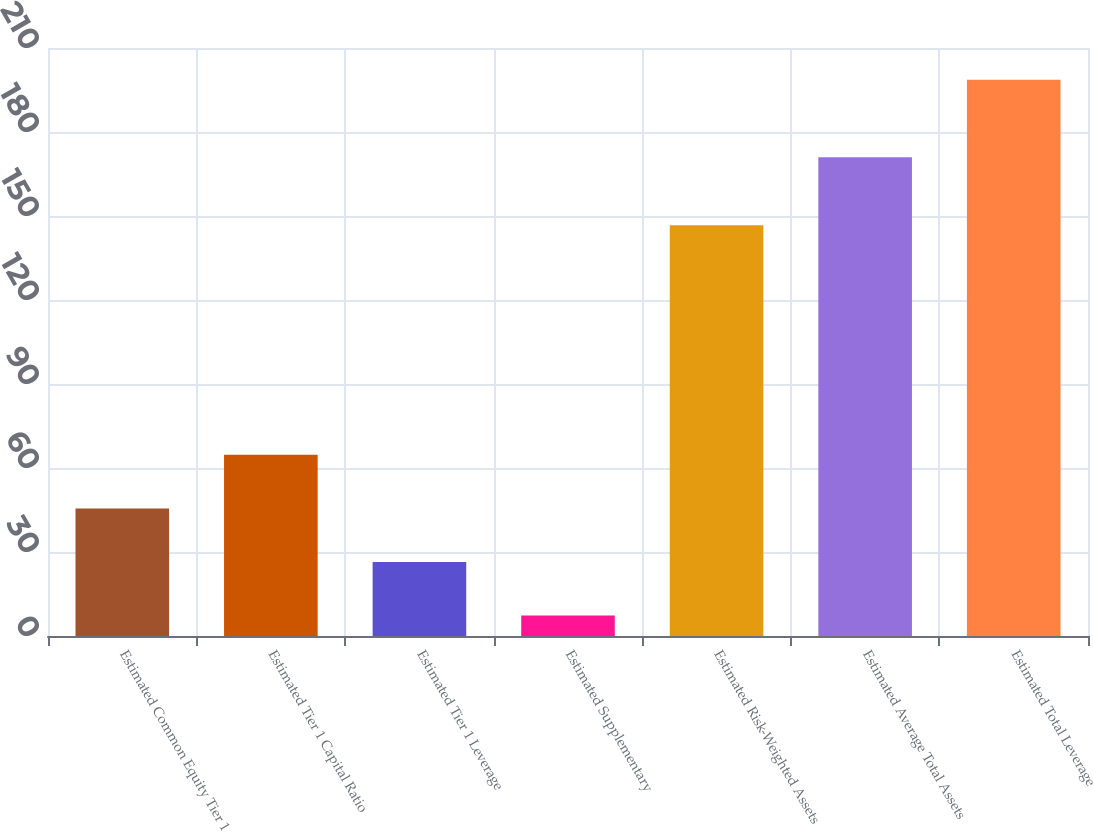Convert chart. <chart><loc_0><loc_0><loc_500><loc_500><bar_chart><fcel>Estimated Common Equity Tier 1<fcel>Estimated Tier 1 Capital Ratio<fcel>Estimated Tier 1 Leverage<fcel>Estimated Supplementary<fcel>Estimated Risk-Weighted Assets<fcel>Estimated Average Total Assets<fcel>Estimated Total Leverage<nl><fcel>45.58<fcel>64.72<fcel>26.44<fcel>7.3<fcel>146.7<fcel>171<fcel>198.7<nl></chart> 